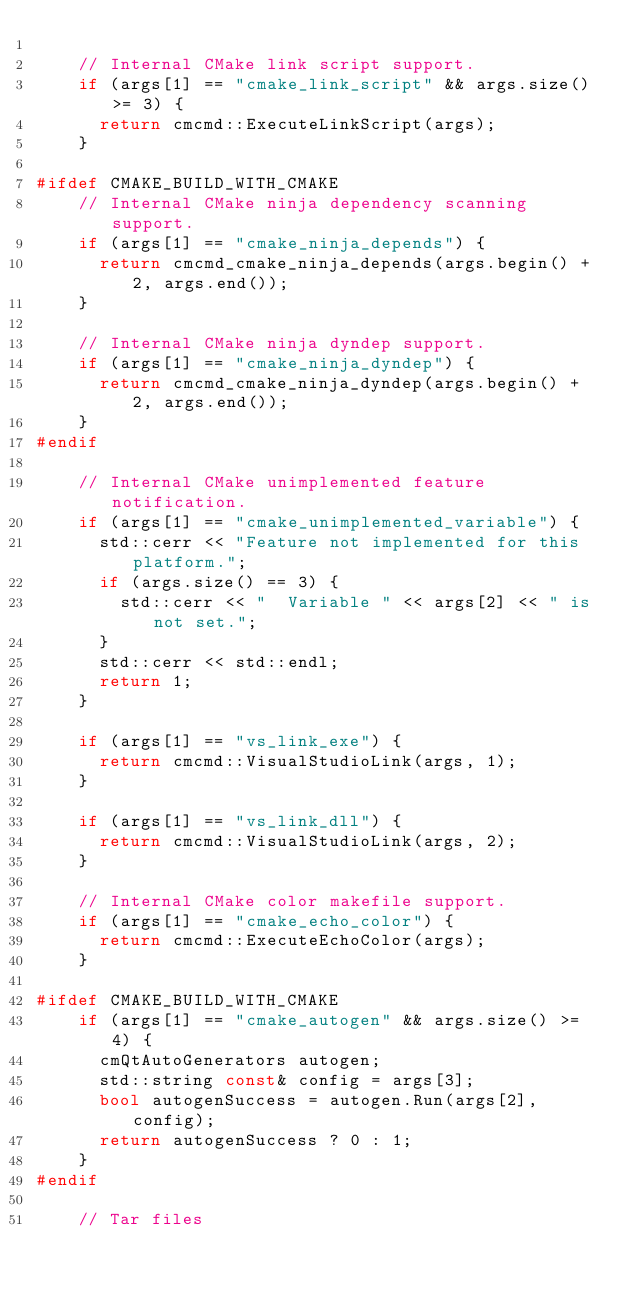Convert code to text. <code><loc_0><loc_0><loc_500><loc_500><_C++_>
    // Internal CMake link script support.
    if (args[1] == "cmake_link_script" && args.size() >= 3) {
      return cmcmd::ExecuteLinkScript(args);
    }

#ifdef CMAKE_BUILD_WITH_CMAKE
    // Internal CMake ninja dependency scanning support.
    if (args[1] == "cmake_ninja_depends") {
      return cmcmd_cmake_ninja_depends(args.begin() + 2, args.end());
    }

    // Internal CMake ninja dyndep support.
    if (args[1] == "cmake_ninja_dyndep") {
      return cmcmd_cmake_ninja_dyndep(args.begin() + 2, args.end());
    }
#endif

    // Internal CMake unimplemented feature notification.
    if (args[1] == "cmake_unimplemented_variable") {
      std::cerr << "Feature not implemented for this platform.";
      if (args.size() == 3) {
        std::cerr << "  Variable " << args[2] << " is not set.";
      }
      std::cerr << std::endl;
      return 1;
    }

    if (args[1] == "vs_link_exe") {
      return cmcmd::VisualStudioLink(args, 1);
    }

    if (args[1] == "vs_link_dll") {
      return cmcmd::VisualStudioLink(args, 2);
    }

    // Internal CMake color makefile support.
    if (args[1] == "cmake_echo_color") {
      return cmcmd::ExecuteEchoColor(args);
    }

#ifdef CMAKE_BUILD_WITH_CMAKE
    if (args[1] == "cmake_autogen" && args.size() >= 4) {
      cmQtAutoGenerators autogen;
      std::string const& config = args[3];
      bool autogenSuccess = autogen.Run(args[2], config);
      return autogenSuccess ? 0 : 1;
    }
#endif

    // Tar files</code> 